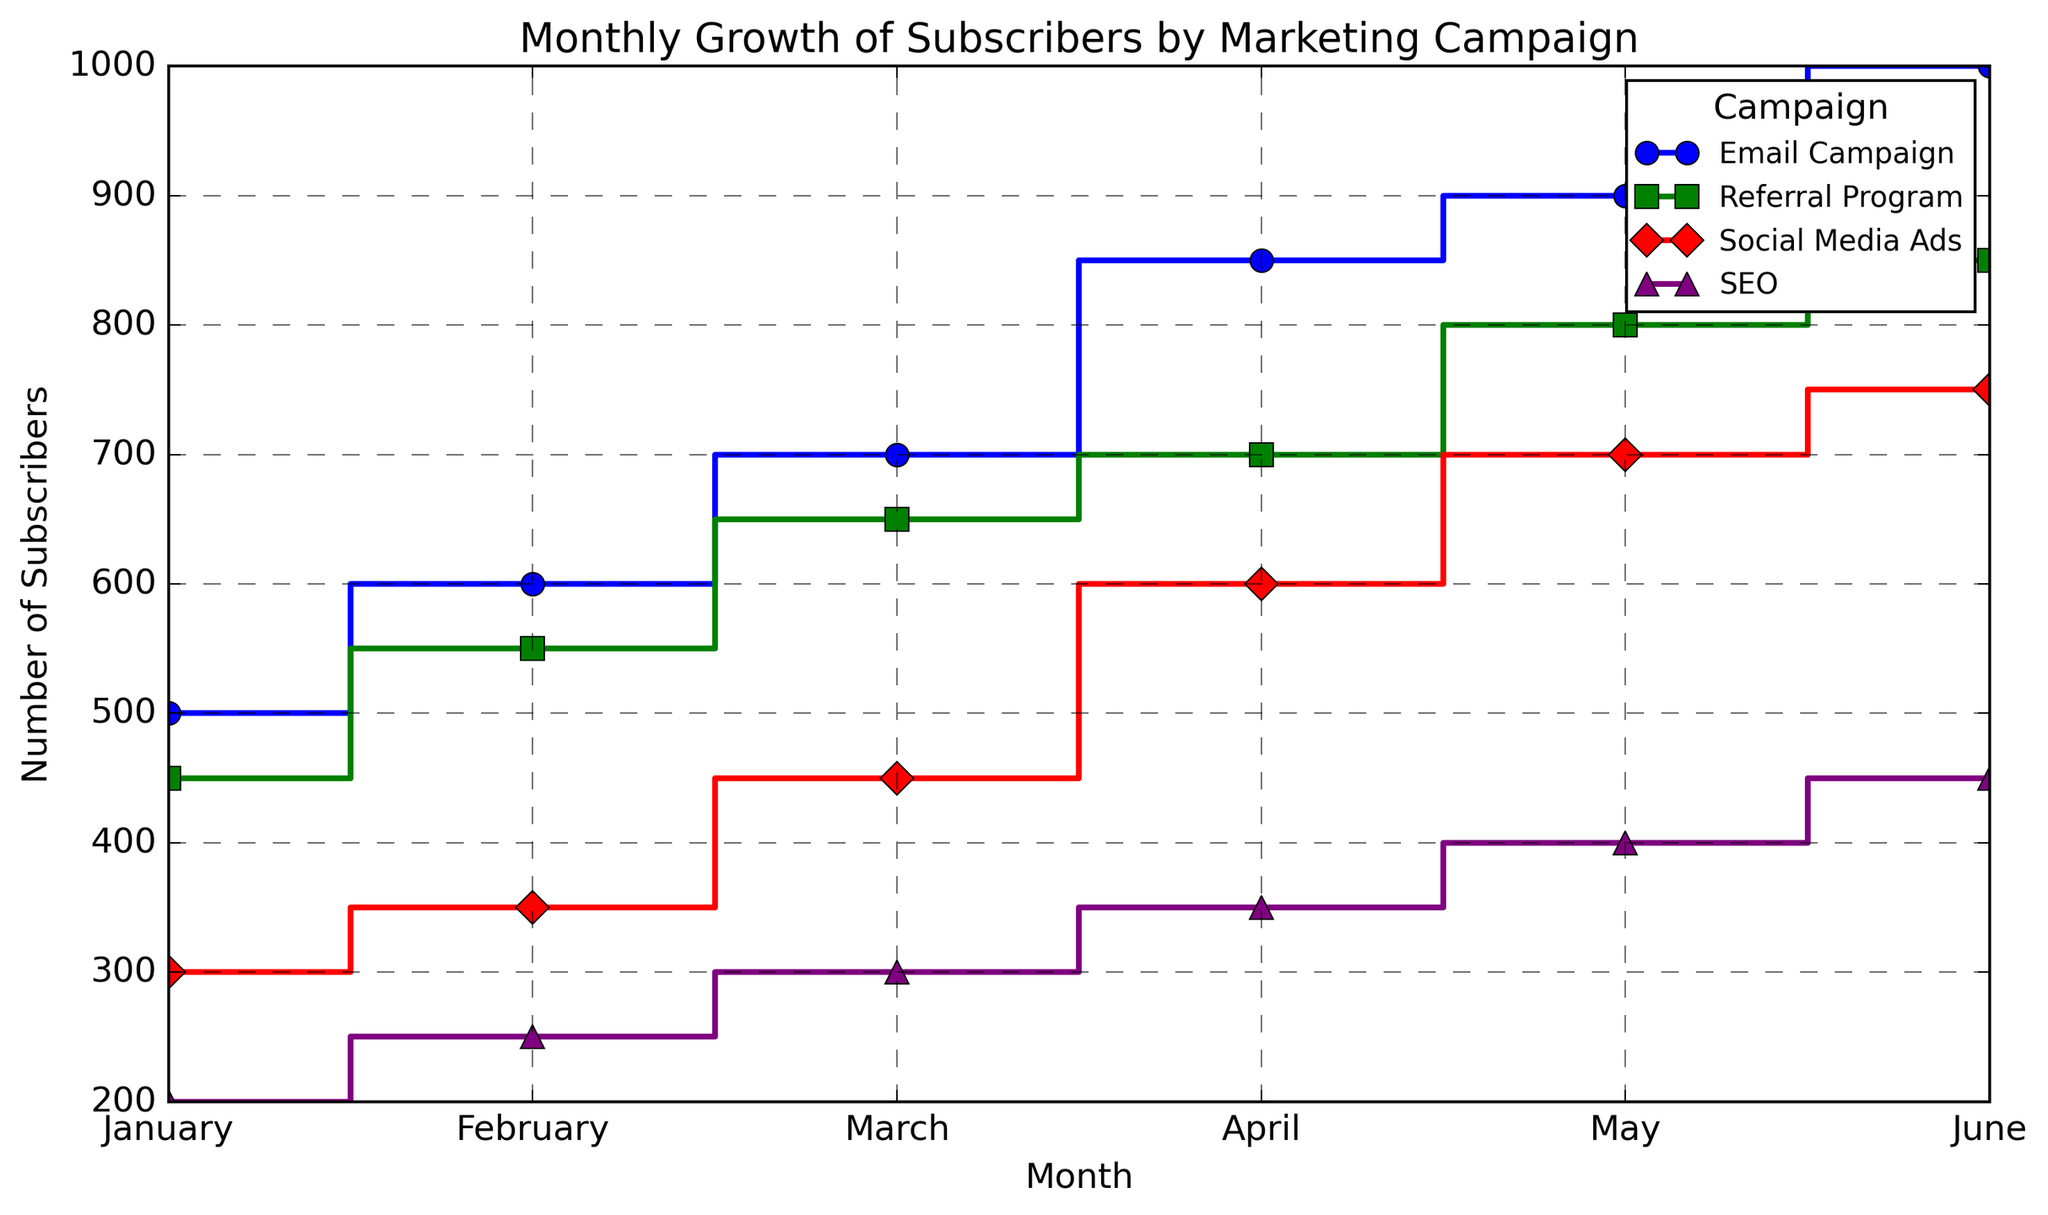What is the number of subscribers for the Email Campaign in March? Identify the point on the plot where 'March' intersects with the line labeled 'Email Campaign'. This point corresponds to 700 subscribers.
Answer: 700 Which marketing campaign had the highest number of subscribers in June? Compare the values of all campaigns in June. The Email Campaign reached 1000, the highest value.
Answer: Email Campaign Between January and June, which campaign showed the most consistent growth? Look for the campaign whose step plot shows the least variation in slope between months. Both the Email Campaign and the Referral Program show consistent growth, but the Referral Program is slightly smoother.
Answer: Referral Program Which month saw the largest increase in subscribers for Social Media Ads? Analyze the vertical jumps in the Social Media Ads plot. The largest increase occurs between March and April, where subscribers jump from 450 to 600.
Answer: April What is the total number of subscribers gained by the SEO campaign from January to June? Calculate the sum of subscribers for the SEO campaign from January (200) to June (450). The total is 200 + 250 + 300 + 350 + 400 + 450 = 1950.
Answer: 1950 Compare the number of subscribers for Referral Program and Social Media Ads in May. Which one had more? Locate the values for both programs in May. The Referral Program had 800 subscribers while Social Media Ads had 700.
Answer: Referral Program Which campaign had the smallest increase in subscribers between February and March? Look at the vertical distance increase between February and March for all campaigns. For each campaign: Email Campaign (100), Referral Program (100), Social Media Ads (100), SEO (50). The smallest increase is for SEO.
Answer: SEO What is the average number of subscribers in June across all campaigns? Calculate the average by summing up the June values (1000 + 850 + 750 + 450) and then dividing by 4. The sum is 3050 and the average is 3050/4 = 762.5.
Answer: 762.5 What color represents the Email Campaign in the plot? Identify the line with the marker representing the Email Campaign, and note its color. The line for the Email Campaign is blue.
Answer: Blue 